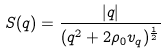Convert formula to latex. <formula><loc_0><loc_0><loc_500><loc_500>S ( { q } ) = \frac { | { q } | } { ( { q } ^ { 2 } + 2 \rho _ { 0 } v _ { q } ) ^ { \frac { 1 } { 2 } } }</formula> 